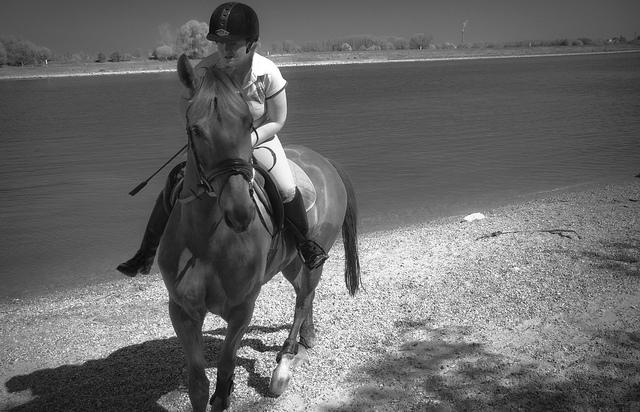Are they playing a sport?
Keep it brief. Yes. What color is the horse?
Answer briefly. Brown. Who is on the horse?
Be succinct. Woman. Is this a fully grown horse?
Write a very short answer. Yes. 